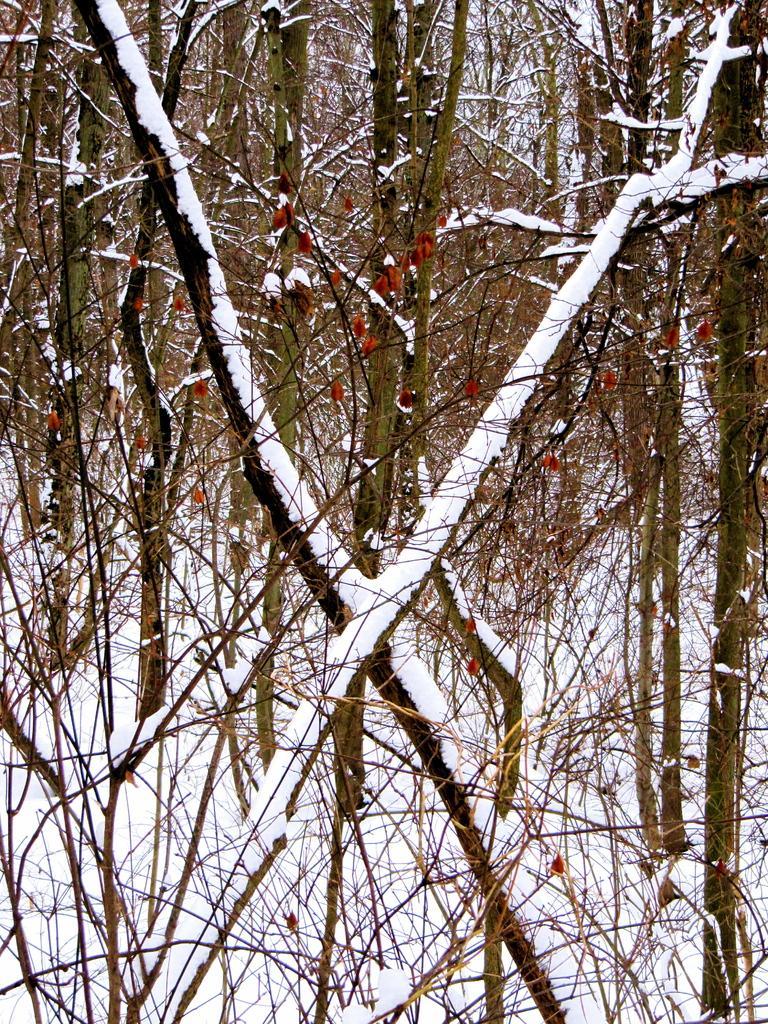Please provide a concise description of this image. In this image there are some trees and the trees are covered with snow, and at the bottom there is snow. 